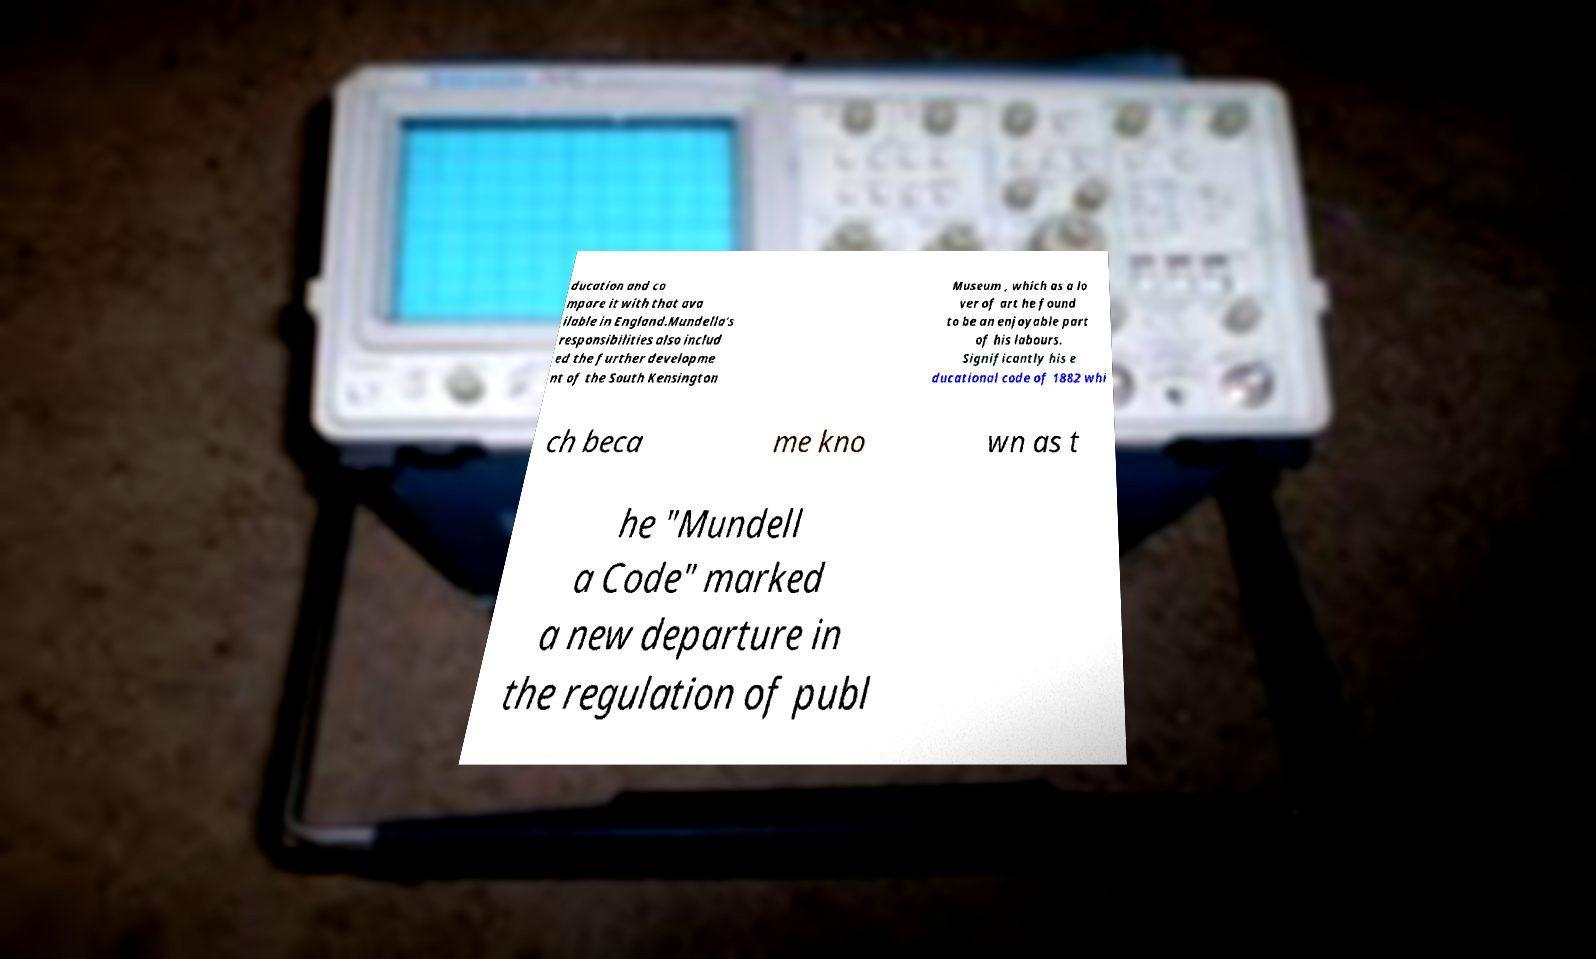Please identify and transcribe the text found in this image. ducation and co mpare it with that ava ilable in England.Mundella's responsibilities also includ ed the further developme nt of the South Kensington Museum , which as a lo ver of art he found to be an enjoyable part of his labours. Significantly his e ducational code of 1882 whi ch beca me kno wn as t he "Mundell a Code" marked a new departure in the regulation of publ 